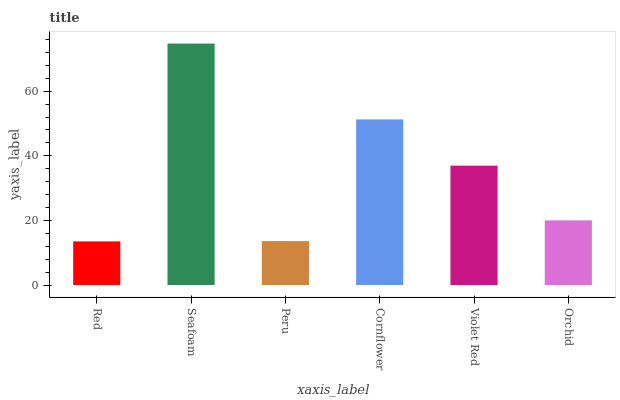Is Red the minimum?
Answer yes or no. Yes. Is Seafoam the maximum?
Answer yes or no. Yes. Is Peru the minimum?
Answer yes or no. No. Is Peru the maximum?
Answer yes or no. No. Is Seafoam greater than Peru?
Answer yes or no. Yes. Is Peru less than Seafoam?
Answer yes or no. Yes. Is Peru greater than Seafoam?
Answer yes or no. No. Is Seafoam less than Peru?
Answer yes or no. No. Is Violet Red the high median?
Answer yes or no. Yes. Is Orchid the low median?
Answer yes or no. Yes. Is Orchid the high median?
Answer yes or no. No. Is Cornflower the low median?
Answer yes or no. No. 